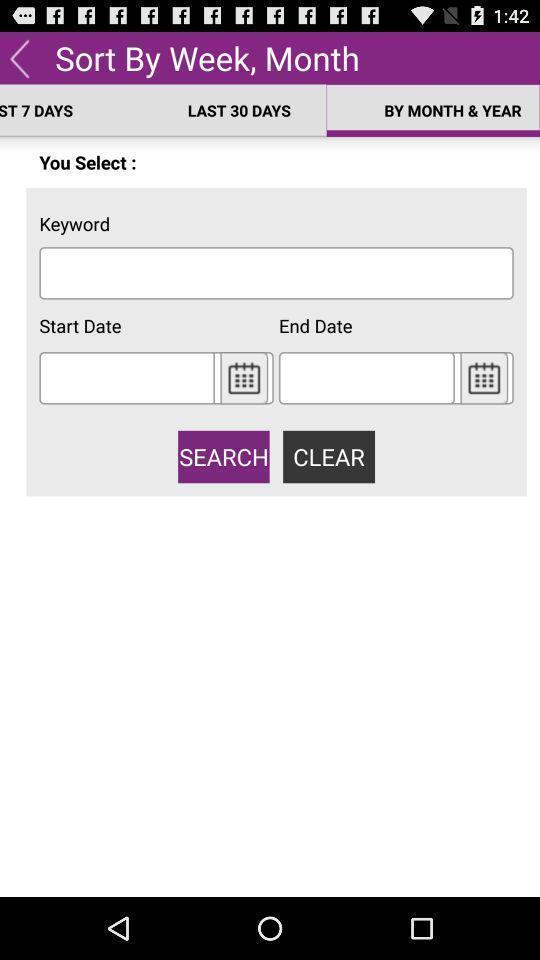Describe the visual elements of this screenshot. Page displaying to sort details by week and month. 